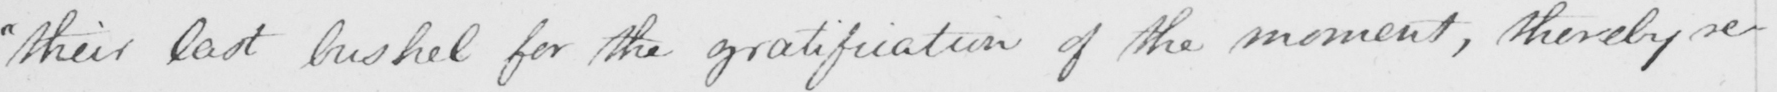Can you read and transcribe this handwriting? " their last bushel for the gratification of the moment , thereby re- 